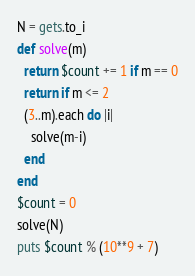<code> <loc_0><loc_0><loc_500><loc_500><_Ruby_>N = gets.to_i
def solve(m)
  return $count += 1 if m == 0
  return if m <= 2
  (3..m).each do |i|
    solve(m-i)
  end
end
$count = 0
solve(N)
puts $count % (10**9 + 7)
</code> 